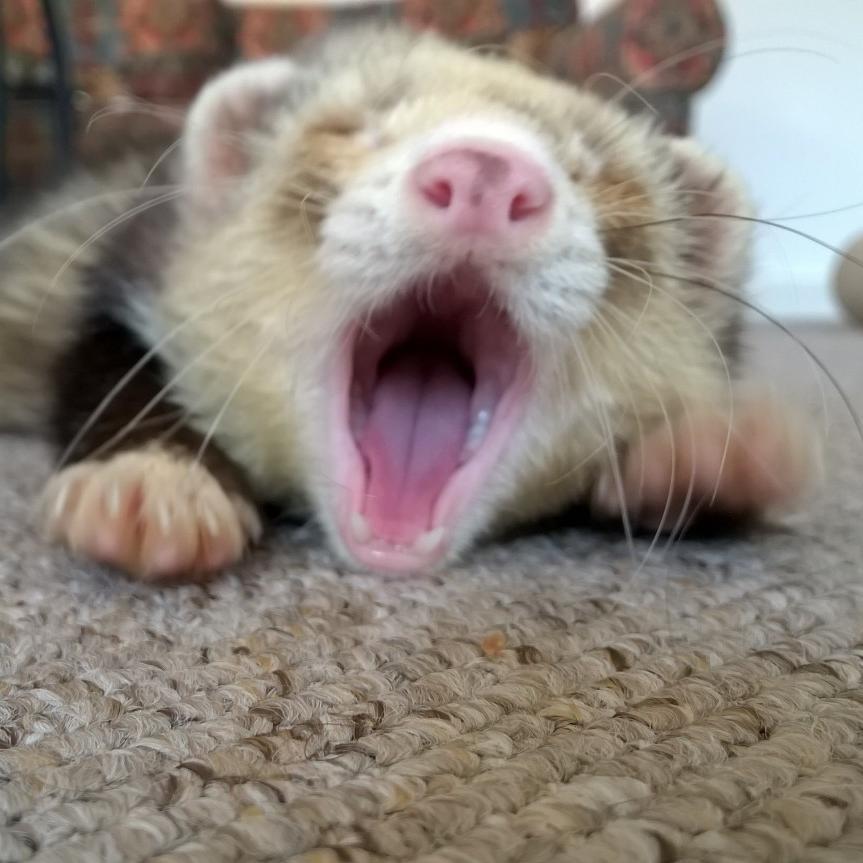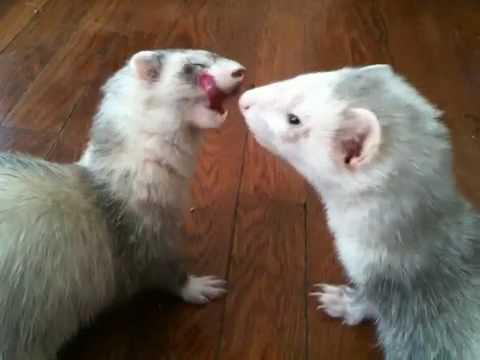The first image is the image on the left, the second image is the image on the right. Assess this claim about the two images: "At least one of the ferrets has their tongue sticking out.". Correct or not? Answer yes or no. Yes. The first image is the image on the left, the second image is the image on the right. For the images shown, is this caption "At least one ferret has an open mouth with tongue showing, and a total of three ferrets are shown." true? Answer yes or no. Yes. 